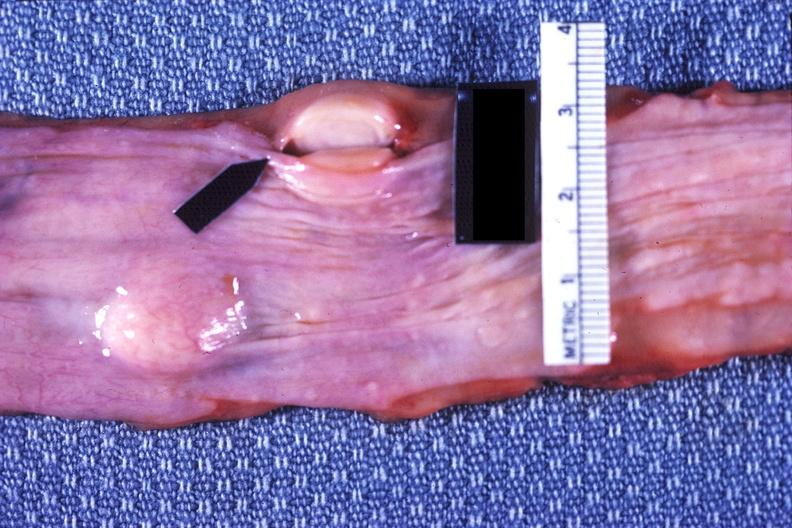what does this image show?
Answer the question using a single word or phrase. Esophagus 